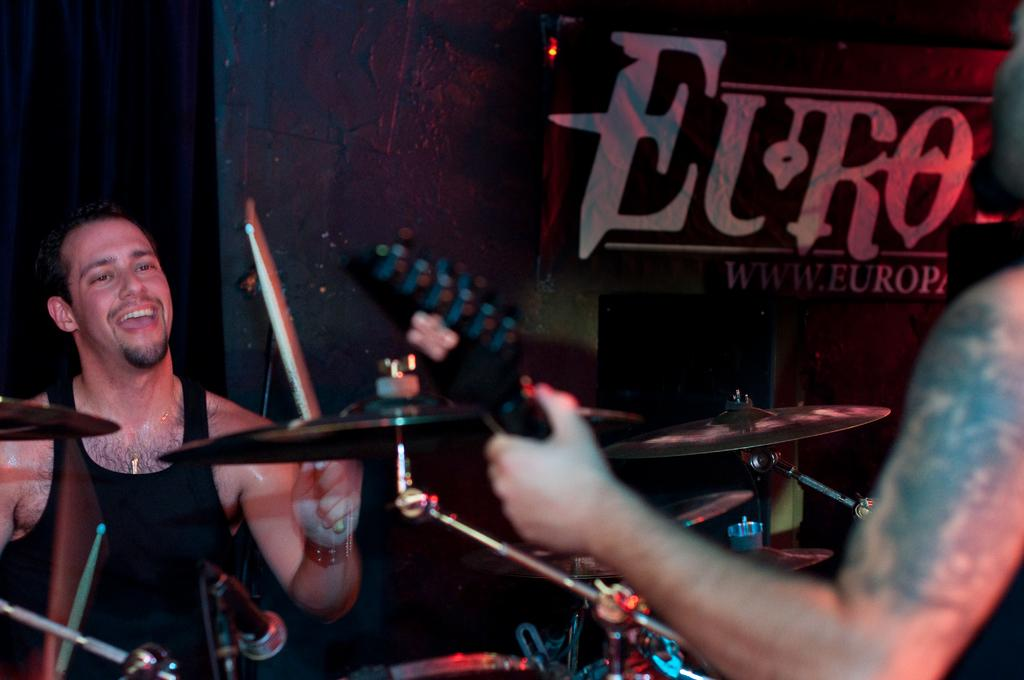What is the man in the image doing? The man is holding a drumstick and playing drums. What other percussion instrument is present in the image? There are cymbals in the image. What equipment is used for amplifying the sound of the vocals? There is a mic stand in the image. What musical instrument is being played by the person in the image? A person is holding a guitar in the image. What can be seen in the background of the image? There is a banner in the background of the image. What type of punishment is being administered to the guitar in the image? There is no punishment being administered to the guitar in the image; it is being played by a person. What kind of pan is being used to cook food in the image? There is no pan present in the image; it is a musical scene featuring a drummer, cymbals, a mic stand, and a guitarist. 